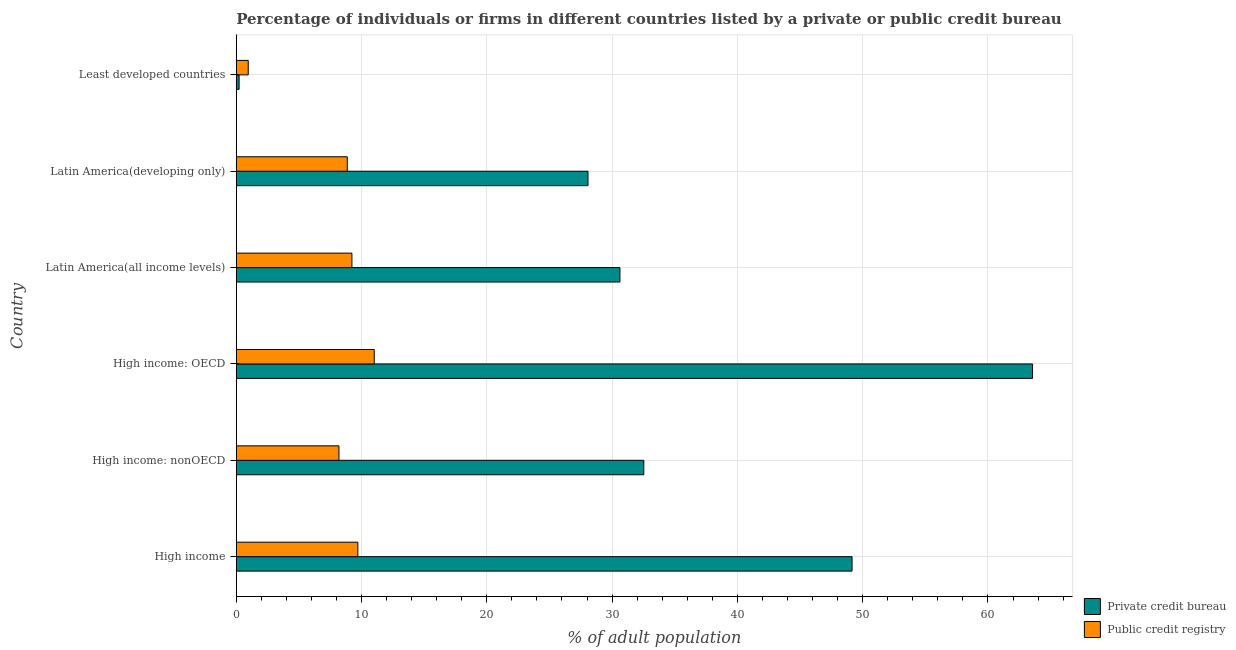How many groups of bars are there?
Offer a terse response. 6. Are the number of bars per tick equal to the number of legend labels?
Provide a succinct answer. Yes. How many bars are there on the 3rd tick from the bottom?
Your answer should be compact. 2. What is the label of the 4th group of bars from the top?
Give a very brief answer. High income: OECD. In how many cases, is the number of bars for a given country not equal to the number of legend labels?
Make the answer very short. 0. What is the percentage of firms listed by private credit bureau in Latin America(all income levels)?
Offer a very short reply. 30.63. Across all countries, what is the maximum percentage of firms listed by public credit bureau?
Provide a short and direct response. 11.01. Across all countries, what is the minimum percentage of firms listed by private credit bureau?
Offer a terse response. 0.23. In which country was the percentage of firms listed by private credit bureau maximum?
Give a very brief answer. High income: OECD. In which country was the percentage of firms listed by public credit bureau minimum?
Your response must be concise. Least developed countries. What is the total percentage of firms listed by public credit bureau in the graph?
Your response must be concise. 47.96. What is the difference between the percentage of firms listed by public credit bureau in High income: OECD and that in High income: nonOECD?
Your answer should be compact. 2.82. What is the difference between the percentage of firms listed by public credit bureau in High income and the percentage of firms listed by private credit bureau in High income: OECD?
Provide a short and direct response. -53.85. What is the average percentage of firms listed by public credit bureau per country?
Ensure brevity in your answer.  7.99. What is the difference between the percentage of firms listed by public credit bureau and percentage of firms listed by private credit bureau in High income?
Keep it short and to the point. -39.45. What is the ratio of the percentage of firms listed by public credit bureau in High income to that in High income: nonOECD?
Offer a very short reply. 1.18. Is the percentage of firms listed by public credit bureau in Latin America(developing only) less than that in Least developed countries?
Your answer should be compact. No. Is the difference between the percentage of firms listed by private credit bureau in High income: OECD and High income: nonOECD greater than the difference between the percentage of firms listed by public credit bureau in High income: OECD and High income: nonOECD?
Make the answer very short. Yes. What is the difference between the highest and the second highest percentage of firms listed by private credit bureau?
Give a very brief answer. 14.41. What is the difference between the highest and the lowest percentage of firms listed by private credit bureau?
Offer a terse response. 63.33. What does the 2nd bar from the top in Latin America(developing only) represents?
Your response must be concise. Private credit bureau. What does the 2nd bar from the bottom in Latin America(developing only) represents?
Offer a very short reply. Public credit registry. How many countries are there in the graph?
Keep it short and to the point. 6. What is the difference between two consecutive major ticks on the X-axis?
Give a very brief answer. 10. Where does the legend appear in the graph?
Your answer should be very brief. Bottom right. What is the title of the graph?
Offer a terse response. Percentage of individuals or firms in different countries listed by a private or public credit bureau. Does "Primary education" appear as one of the legend labels in the graph?
Offer a terse response. No. What is the label or title of the X-axis?
Offer a very short reply. % of adult population. What is the label or title of the Y-axis?
Provide a succinct answer. Country. What is the % of adult population in Private credit bureau in High income?
Give a very brief answer. 49.15. What is the % of adult population in Public credit registry in High income?
Your answer should be very brief. 9.71. What is the % of adult population of Private credit bureau in High income: nonOECD?
Your answer should be compact. 32.53. What is the % of adult population in Public credit registry in High income: nonOECD?
Your answer should be compact. 8.2. What is the % of adult population in Private credit bureau in High income: OECD?
Your answer should be compact. 63.56. What is the % of adult population of Public credit registry in High income: OECD?
Provide a succinct answer. 11.01. What is the % of adult population of Private credit bureau in Latin America(all income levels)?
Make the answer very short. 30.63. What is the % of adult population of Public credit registry in Latin America(all income levels)?
Your response must be concise. 9.23. What is the % of adult population of Private credit bureau in Latin America(developing only)?
Give a very brief answer. 28.08. What is the % of adult population of Public credit registry in Latin America(developing only)?
Keep it short and to the point. 8.86. What is the % of adult population of Private credit bureau in Least developed countries?
Your answer should be very brief. 0.23. What is the % of adult population of Public credit registry in Least developed countries?
Provide a succinct answer. 0.96. Across all countries, what is the maximum % of adult population in Private credit bureau?
Give a very brief answer. 63.56. Across all countries, what is the maximum % of adult population in Public credit registry?
Your answer should be very brief. 11.01. Across all countries, what is the minimum % of adult population of Private credit bureau?
Ensure brevity in your answer.  0.23. Across all countries, what is the minimum % of adult population of Public credit registry?
Ensure brevity in your answer.  0.96. What is the total % of adult population of Private credit bureau in the graph?
Keep it short and to the point. 204.17. What is the total % of adult population in Public credit registry in the graph?
Your answer should be compact. 47.96. What is the difference between the % of adult population of Private credit bureau in High income and that in High income: nonOECD?
Ensure brevity in your answer.  16.62. What is the difference between the % of adult population in Public credit registry in High income and that in High income: nonOECD?
Your answer should be very brief. 1.51. What is the difference between the % of adult population in Private credit bureau in High income and that in High income: OECD?
Offer a terse response. -14.41. What is the difference between the % of adult population of Public credit registry in High income and that in High income: OECD?
Provide a succinct answer. -1.31. What is the difference between the % of adult population of Private credit bureau in High income and that in Latin America(all income levels)?
Provide a short and direct response. 18.53. What is the difference between the % of adult population in Public credit registry in High income and that in Latin America(all income levels)?
Make the answer very short. 0.47. What is the difference between the % of adult population in Private credit bureau in High income and that in Latin America(developing only)?
Make the answer very short. 21.08. What is the difference between the % of adult population in Public credit registry in High income and that in Latin America(developing only)?
Your answer should be very brief. 0.84. What is the difference between the % of adult population in Private credit bureau in High income and that in Least developed countries?
Your answer should be very brief. 48.93. What is the difference between the % of adult population of Public credit registry in High income and that in Least developed countries?
Provide a short and direct response. 8.75. What is the difference between the % of adult population of Private credit bureau in High income: nonOECD and that in High income: OECD?
Offer a very short reply. -31.03. What is the difference between the % of adult population in Public credit registry in High income: nonOECD and that in High income: OECD?
Offer a terse response. -2.82. What is the difference between the % of adult population of Private credit bureau in High income: nonOECD and that in Latin America(all income levels)?
Provide a succinct answer. 1.91. What is the difference between the % of adult population of Public credit registry in High income: nonOECD and that in Latin America(all income levels)?
Keep it short and to the point. -1.04. What is the difference between the % of adult population in Private credit bureau in High income: nonOECD and that in Latin America(developing only)?
Ensure brevity in your answer.  4.45. What is the difference between the % of adult population in Public credit registry in High income: nonOECD and that in Latin America(developing only)?
Give a very brief answer. -0.67. What is the difference between the % of adult population in Private credit bureau in High income: nonOECD and that in Least developed countries?
Offer a very short reply. 32.3. What is the difference between the % of adult population in Public credit registry in High income: nonOECD and that in Least developed countries?
Provide a short and direct response. 7.24. What is the difference between the % of adult population in Private credit bureau in High income: OECD and that in Latin America(all income levels)?
Offer a very short reply. 32.93. What is the difference between the % of adult population in Public credit registry in High income: OECD and that in Latin America(all income levels)?
Your answer should be very brief. 1.78. What is the difference between the % of adult population in Private credit bureau in High income: OECD and that in Latin America(developing only)?
Your response must be concise. 35.48. What is the difference between the % of adult population of Public credit registry in High income: OECD and that in Latin America(developing only)?
Offer a very short reply. 2.15. What is the difference between the % of adult population of Private credit bureau in High income: OECD and that in Least developed countries?
Your answer should be compact. 63.33. What is the difference between the % of adult population in Public credit registry in High income: OECD and that in Least developed countries?
Your answer should be very brief. 10.06. What is the difference between the % of adult population in Private credit bureau in Latin America(all income levels) and that in Latin America(developing only)?
Your answer should be very brief. 2.55. What is the difference between the % of adult population in Public credit registry in Latin America(all income levels) and that in Latin America(developing only)?
Ensure brevity in your answer.  0.37. What is the difference between the % of adult population in Private credit bureau in Latin America(all income levels) and that in Least developed countries?
Ensure brevity in your answer.  30.4. What is the difference between the % of adult population of Public credit registry in Latin America(all income levels) and that in Least developed countries?
Your answer should be very brief. 8.28. What is the difference between the % of adult population of Private credit bureau in Latin America(developing only) and that in Least developed countries?
Your answer should be very brief. 27.85. What is the difference between the % of adult population of Public credit registry in Latin America(developing only) and that in Least developed countries?
Give a very brief answer. 7.91. What is the difference between the % of adult population in Private credit bureau in High income and the % of adult population in Public credit registry in High income: nonOECD?
Offer a terse response. 40.96. What is the difference between the % of adult population of Private credit bureau in High income and the % of adult population of Public credit registry in High income: OECD?
Provide a succinct answer. 38.14. What is the difference between the % of adult population in Private credit bureau in High income and the % of adult population in Public credit registry in Latin America(all income levels)?
Offer a terse response. 39.92. What is the difference between the % of adult population of Private credit bureau in High income and the % of adult population of Public credit registry in Latin America(developing only)?
Your answer should be very brief. 40.29. What is the difference between the % of adult population of Private credit bureau in High income and the % of adult population of Public credit registry in Least developed countries?
Your response must be concise. 48.2. What is the difference between the % of adult population of Private credit bureau in High income: nonOECD and the % of adult population of Public credit registry in High income: OECD?
Your response must be concise. 21.52. What is the difference between the % of adult population in Private credit bureau in High income: nonOECD and the % of adult population in Public credit registry in Latin America(all income levels)?
Your answer should be very brief. 23.3. What is the difference between the % of adult population of Private credit bureau in High income: nonOECD and the % of adult population of Public credit registry in Latin America(developing only)?
Your response must be concise. 23.67. What is the difference between the % of adult population in Private credit bureau in High income: nonOECD and the % of adult population in Public credit registry in Least developed countries?
Your response must be concise. 31.57. What is the difference between the % of adult population in Private credit bureau in High income: OECD and the % of adult population in Public credit registry in Latin America(all income levels)?
Offer a very short reply. 54.33. What is the difference between the % of adult population in Private credit bureau in High income: OECD and the % of adult population in Public credit registry in Latin America(developing only)?
Your answer should be very brief. 54.7. What is the difference between the % of adult population in Private credit bureau in High income: OECD and the % of adult population in Public credit registry in Least developed countries?
Provide a short and direct response. 62.6. What is the difference between the % of adult population of Private credit bureau in Latin America(all income levels) and the % of adult population of Public credit registry in Latin America(developing only)?
Give a very brief answer. 21.76. What is the difference between the % of adult population of Private credit bureau in Latin America(all income levels) and the % of adult population of Public credit registry in Least developed countries?
Your answer should be very brief. 29.67. What is the difference between the % of adult population of Private credit bureau in Latin America(developing only) and the % of adult population of Public credit registry in Least developed countries?
Your response must be concise. 27.12. What is the average % of adult population of Private credit bureau per country?
Keep it short and to the point. 34.03. What is the average % of adult population in Public credit registry per country?
Make the answer very short. 7.99. What is the difference between the % of adult population in Private credit bureau and % of adult population in Public credit registry in High income?
Your answer should be compact. 39.45. What is the difference between the % of adult population in Private credit bureau and % of adult population in Public credit registry in High income: nonOECD?
Your answer should be compact. 24.33. What is the difference between the % of adult population in Private credit bureau and % of adult population in Public credit registry in High income: OECD?
Provide a short and direct response. 52.55. What is the difference between the % of adult population in Private credit bureau and % of adult population in Public credit registry in Latin America(all income levels)?
Provide a short and direct response. 21.39. What is the difference between the % of adult population of Private credit bureau and % of adult population of Public credit registry in Latin America(developing only)?
Your response must be concise. 19.21. What is the difference between the % of adult population in Private credit bureau and % of adult population in Public credit registry in Least developed countries?
Provide a short and direct response. -0.73. What is the ratio of the % of adult population in Private credit bureau in High income to that in High income: nonOECD?
Give a very brief answer. 1.51. What is the ratio of the % of adult population of Public credit registry in High income to that in High income: nonOECD?
Keep it short and to the point. 1.18. What is the ratio of the % of adult population in Private credit bureau in High income to that in High income: OECD?
Give a very brief answer. 0.77. What is the ratio of the % of adult population in Public credit registry in High income to that in High income: OECD?
Your response must be concise. 0.88. What is the ratio of the % of adult population in Private credit bureau in High income to that in Latin America(all income levels)?
Give a very brief answer. 1.6. What is the ratio of the % of adult population in Public credit registry in High income to that in Latin America(all income levels)?
Provide a short and direct response. 1.05. What is the ratio of the % of adult population of Private credit bureau in High income to that in Latin America(developing only)?
Ensure brevity in your answer.  1.75. What is the ratio of the % of adult population in Public credit registry in High income to that in Latin America(developing only)?
Give a very brief answer. 1.1. What is the ratio of the % of adult population of Private credit bureau in High income to that in Least developed countries?
Provide a succinct answer. 215.67. What is the ratio of the % of adult population of Public credit registry in High income to that in Least developed countries?
Offer a terse response. 10.15. What is the ratio of the % of adult population in Private credit bureau in High income: nonOECD to that in High income: OECD?
Offer a terse response. 0.51. What is the ratio of the % of adult population in Public credit registry in High income: nonOECD to that in High income: OECD?
Your response must be concise. 0.74. What is the ratio of the % of adult population of Private credit bureau in High income: nonOECD to that in Latin America(all income levels)?
Ensure brevity in your answer.  1.06. What is the ratio of the % of adult population in Public credit registry in High income: nonOECD to that in Latin America(all income levels)?
Keep it short and to the point. 0.89. What is the ratio of the % of adult population in Private credit bureau in High income: nonOECD to that in Latin America(developing only)?
Make the answer very short. 1.16. What is the ratio of the % of adult population in Public credit registry in High income: nonOECD to that in Latin America(developing only)?
Keep it short and to the point. 0.92. What is the ratio of the % of adult population in Private credit bureau in High income: nonOECD to that in Least developed countries?
Give a very brief answer. 142.74. What is the ratio of the % of adult population in Public credit registry in High income: nonOECD to that in Least developed countries?
Your response must be concise. 8.58. What is the ratio of the % of adult population in Private credit bureau in High income: OECD to that in Latin America(all income levels)?
Keep it short and to the point. 2.08. What is the ratio of the % of adult population of Public credit registry in High income: OECD to that in Latin America(all income levels)?
Make the answer very short. 1.19. What is the ratio of the % of adult population of Private credit bureau in High income: OECD to that in Latin America(developing only)?
Offer a terse response. 2.26. What is the ratio of the % of adult population in Public credit registry in High income: OECD to that in Latin America(developing only)?
Keep it short and to the point. 1.24. What is the ratio of the % of adult population of Private credit bureau in High income: OECD to that in Least developed countries?
Offer a terse response. 278.89. What is the ratio of the % of adult population in Public credit registry in High income: OECD to that in Least developed countries?
Provide a succinct answer. 11.52. What is the ratio of the % of adult population in Private credit bureau in Latin America(all income levels) to that in Latin America(developing only)?
Your response must be concise. 1.09. What is the ratio of the % of adult population in Public credit registry in Latin America(all income levels) to that in Latin America(developing only)?
Make the answer very short. 1.04. What is the ratio of the % of adult population of Private credit bureau in Latin America(all income levels) to that in Least developed countries?
Keep it short and to the point. 134.38. What is the ratio of the % of adult population in Public credit registry in Latin America(all income levels) to that in Least developed countries?
Provide a short and direct response. 9.66. What is the ratio of the % of adult population of Private credit bureau in Latin America(developing only) to that in Least developed countries?
Your answer should be compact. 123.19. What is the ratio of the % of adult population in Public credit registry in Latin America(developing only) to that in Least developed countries?
Ensure brevity in your answer.  9.27. What is the difference between the highest and the second highest % of adult population of Private credit bureau?
Provide a short and direct response. 14.41. What is the difference between the highest and the second highest % of adult population in Public credit registry?
Your answer should be compact. 1.31. What is the difference between the highest and the lowest % of adult population of Private credit bureau?
Give a very brief answer. 63.33. What is the difference between the highest and the lowest % of adult population in Public credit registry?
Your answer should be very brief. 10.06. 